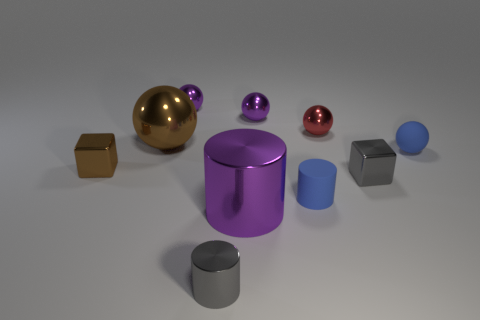Is the number of cubes that are in front of the tiny matte cylinder less than the number of large brown shiny spheres that are in front of the brown ball?
Offer a very short reply. No. Are there any other things that have the same shape as the large brown object?
Your answer should be very brief. Yes. There is a sphere that is the same color as the matte cylinder; what is its material?
Offer a very short reply. Rubber. How many balls are behind the blue matte object that is behind the small matte thing left of the rubber ball?
Keep it short and to the point. 4. What number of gray cubes are in front of the tiny blue matte cylinder?
Your response must be concise. 0. What number of small gray cubes have the same material as the small blue ball?
Provide a succinct answer. 0. There is another cylinder that is made of the same material as the gray cylinder; what is its color?
Ensure brevity in your answer.  Purple. There is a thing that is in front of the purple object in front of the gray shiny thing behind the blue matte cylinder; what is its material?
Make the answer very short. Metal. There is a metal block that is right of the red metallic ball; does it have the same size as the red object?
Your answer should be very brief. Yes. What number of big objects are purple metal balls or yellow rubber cylinders?
Your answer should be very brief. 0. 